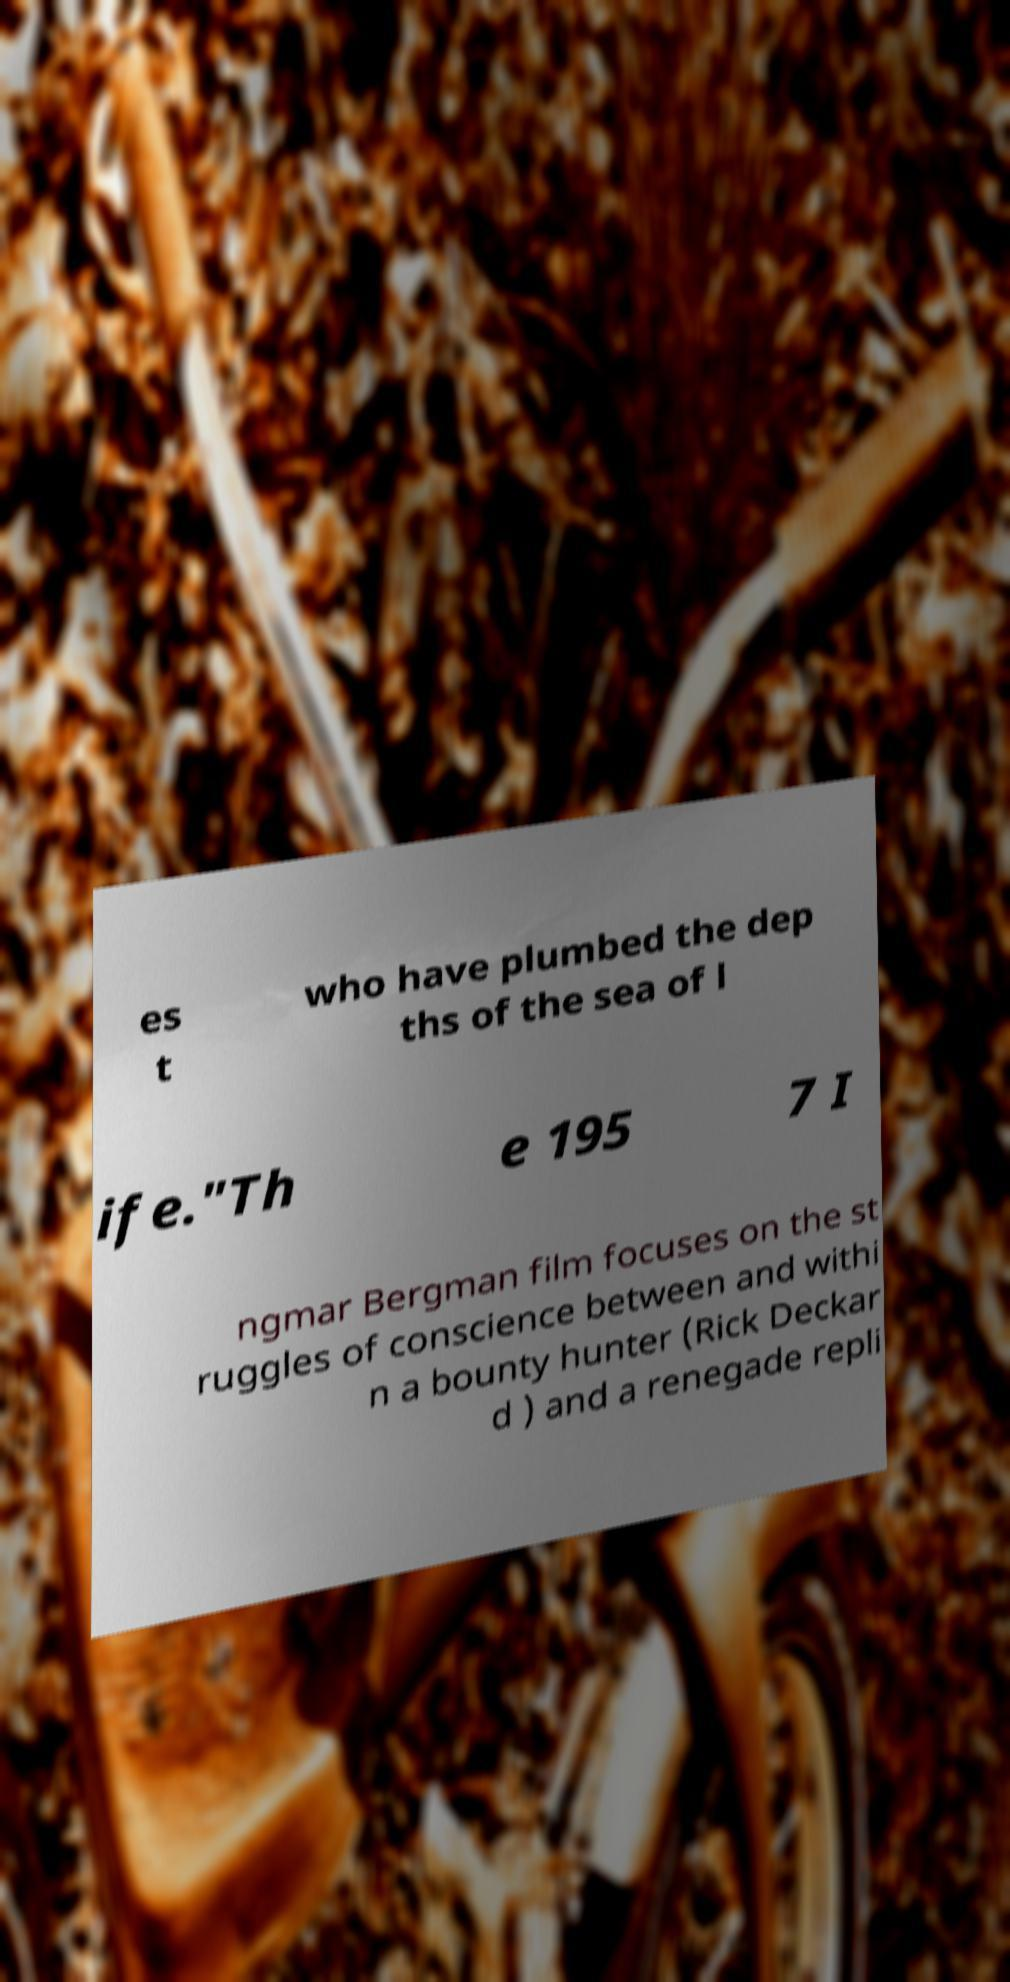Could you extract and type out the text from this image? es t who have plumbed the dep ths of the sea of l ife."Th e 195 7 I ngmar Bergman film focuses on the st ruggles of conscience between and withi n a bounty hunter (Rick Deckar d ) and a renegade repli 